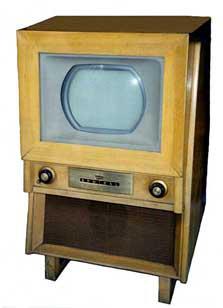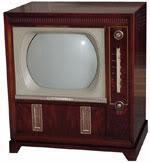The first image is the image on the left, the second image is the image on the right. Given the left and right images, does the statement "All televisions are large tube screens in wooden cabinets." hold true? Answer yes or no. Yes. 